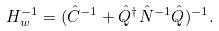<formula> <loc_0><loc_0><loc_500><loc_500>H _ { w } ^ { - 1 } = ( \hat { C } ^ { - 1 } + \hat { Q } ^ { \dagger } \hat { N } ^ { - 1 } \hat { Q } ) ^ { - 1 } .</formula> 